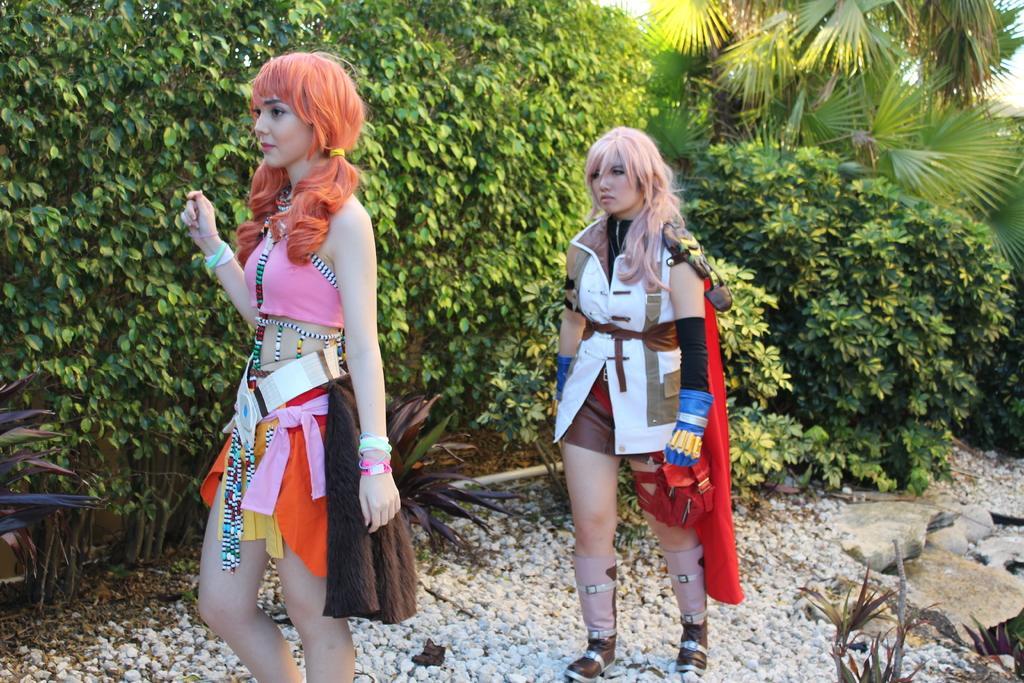In one or two sentences, can you explain what this image depicts? In this picture there are two girls standing. At the back there are trees. At the top there is sky. At the bottom there are stones and plants and there is a pipe. 